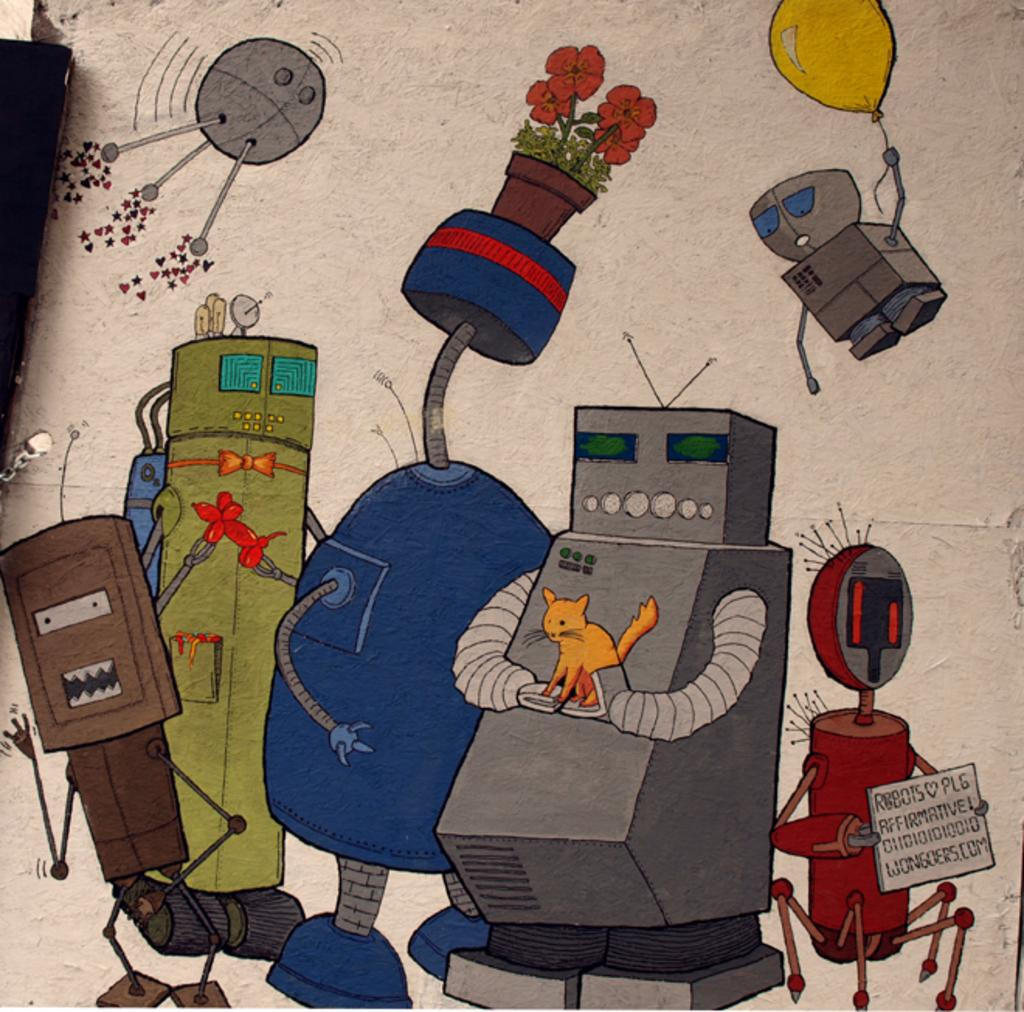What is present on the wall in the image? There is a painting of a plant on the wall. What can be seen within the painting? The painting features electrical equipment, a cat, and a water pipe. What type of room is depicted in the painting? The painting does not depict a room; it features a plant, electrical equipment, a cat, and a water pipe. Is there a fight happening in the painting? There is no fight depicted in the painting; it focuses on the plant, electrical equipment, cat, and water pipe. 